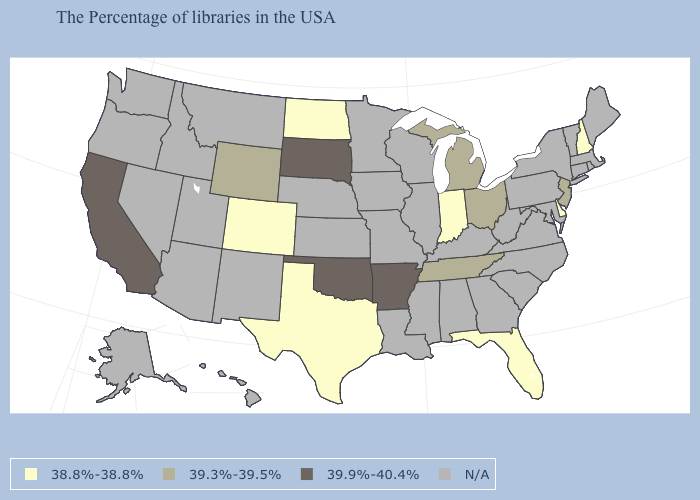Does the map have missing data?
Give a very brief answer. Yes. What is the value of Colorado?
Concise answer only. 38.8%-38.8%. What is the value of Nevada?
Short answer required. N/A. How many symbols are there in the legend?
Write a very short answer. 4. Is the legend a continuous bar?
Keep it brief. No. Does Florida have the lowest value in the USA?
Quick response, please. Yes. What is the value of Maryland?
Quick response, please. N/A. Name the states that have a value in the range 39.9%-40.4%?
Answer briefly. Arkansas, Oklahoma, South Dakota, California. What is the value of Delaware?
Write a very short answer. 38.8%-38.8%. Name the states that have a value in the range 38.8%-38.8%?
Write a very short answer. New Hampshire, Delaware, Florida, Indiana, Texas, North Dakota, Colorado. What is the value of West Virginia?
Be succinct. N/A. Among the states that border Ohio , does Indiana have the lowest value?
Be succinct. Yes. Name the states that have a value in the range N/A?
Answer briefly. Maine, Massachusetts, Rhode Island, Vermont, Connecticut, New York, Maryland, Pennsylvania, Virginia, North Carolina, South Carolina, West Virginia, Georgia, Kentucky, Alabama, Wisconsin, Illinois, Mississippi, Louisiana, Missouri, Minnesota, Iowa, Kansas, Nebraska, New Mexico, Utah, Montana, Arizona, Idaho, Nevada, Washington, Oregon, Alaska, Hawaii. Does the map have missing data?
Be succinct. Yes. 